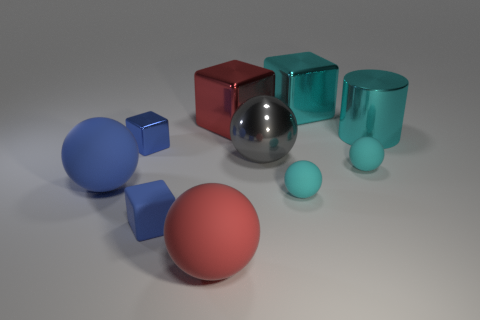The small thing that is to the left of the red shiny cube and in front of the small blue metallic thing is what color?
Provide a short and direct response. Blue. What material is the big cyan cylinder?
Your response must be concise. Metal. There is a red thing that is behind the big metal cylinder; what shape is it?
Offer a terse response. Cube. What is the color of the matte thing that is the same size as the blue sphere?
Your answer should be compact. Red. Does the cyan object that is behind the big cyan shiny cylinder have the same material as the large gray object?
Your response must be concise. Yes. There is a thing that is behind the metal sphere and on the left side of the big red sphere; how big is it?
Offer a very short reply. Small. There is a red object behind the red rubber object; what size is it?
Provide a succinct answer. Large. There is a big metal thing that is the same color as the large cylinder; what shape is it?
Provide a succinct answer. Cube. There is a tiny matte thing on the right side of the big cyan object behind the metal object on the right side of the big cyan metallic block; what shape is it?
Provide a succinct answer. Sphere. How many other things are there of the same shape as the big red shiny object?
Offer a very short reply. 3. 